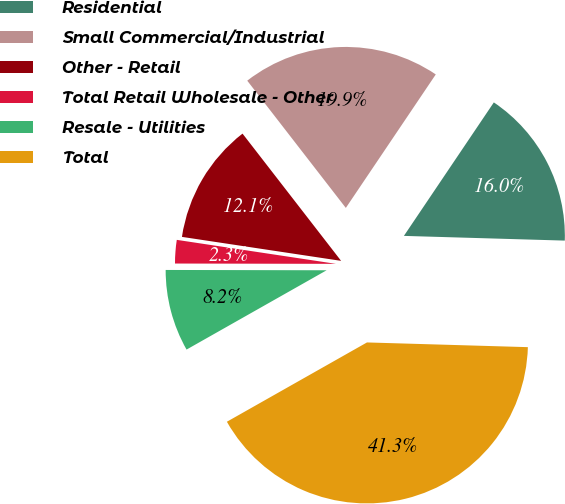Convert chart to OTSL. <chart><loc_0><loc_0><loc_500><loc_500><pie_chart><fcel>Residential<fcel>Small Commercial/Industrial<fcel>Other - Retail<fcel>Total Retail Wholesale - Other<fcel>Resale - Utilities<fcel>Total<nl><fcel>16.03%<fcel>19.93%<fcel>12.13%<fcel>2.35%<fcel>8.23%<fcel>41.34%<nl></chart> 